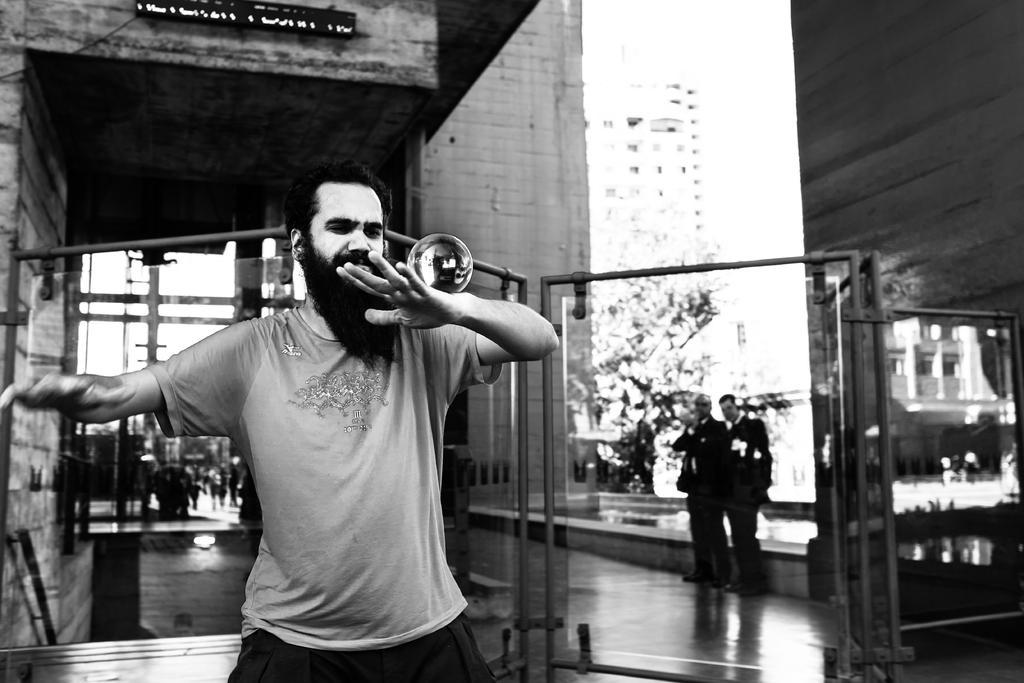In one or two sentences, can you explain what this image depicts? In this image I can see the person with the glass ball. At the back of the person I can see the rods and the two more people with dresses. In the background I can see the board to one of the building. I can also see the trees. 